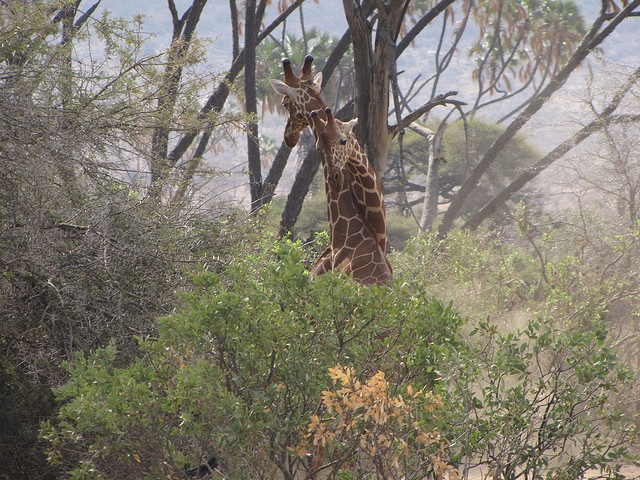Describe the objects in this image and their specific colors. I can see giraffe in gray and maroon tones and giraffe in gray, maroon, and black tones in this image. 